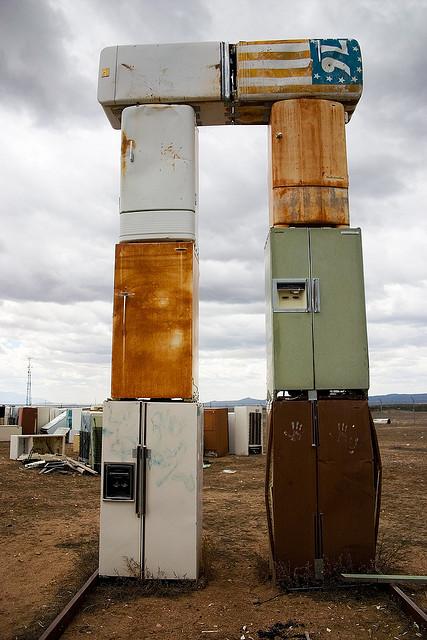What is the name of the objects that make up the formation?
Short answer required. Refrigerators. Do you see the sun?
Be succinct. No. What is the place of this structure?
Quick response, please. Junkyard. 